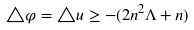<formula> <loc_0><loc_0><loc_500><loc_500>\triangle \varphi = \triangle u \geq - ( 2 n ^ { 2 } \Lambda + n )</formula> 